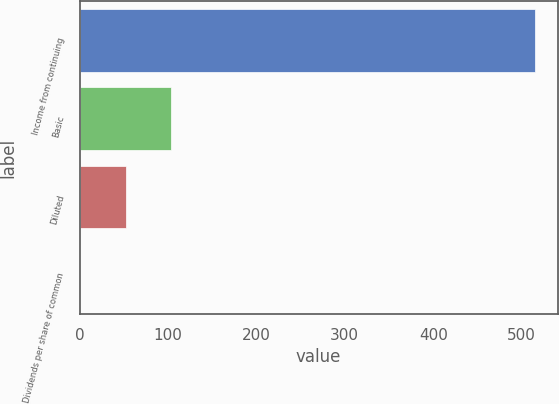<chart> <loc_0><loc_0><loc_500><loc_500><bar_chart><fcel>Income from continuing<fcel>Basic<fcel>Diluted<fcel>Dividends per share of common<nl><fcel>514.9<fcel>103.5<fcel>52.07<fcel>0.64<nl></chart> 